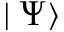Convert formula to latex. <formula><loc_0><loc_0><loc_500><loc_500>| \Psi \rangle</formula> 